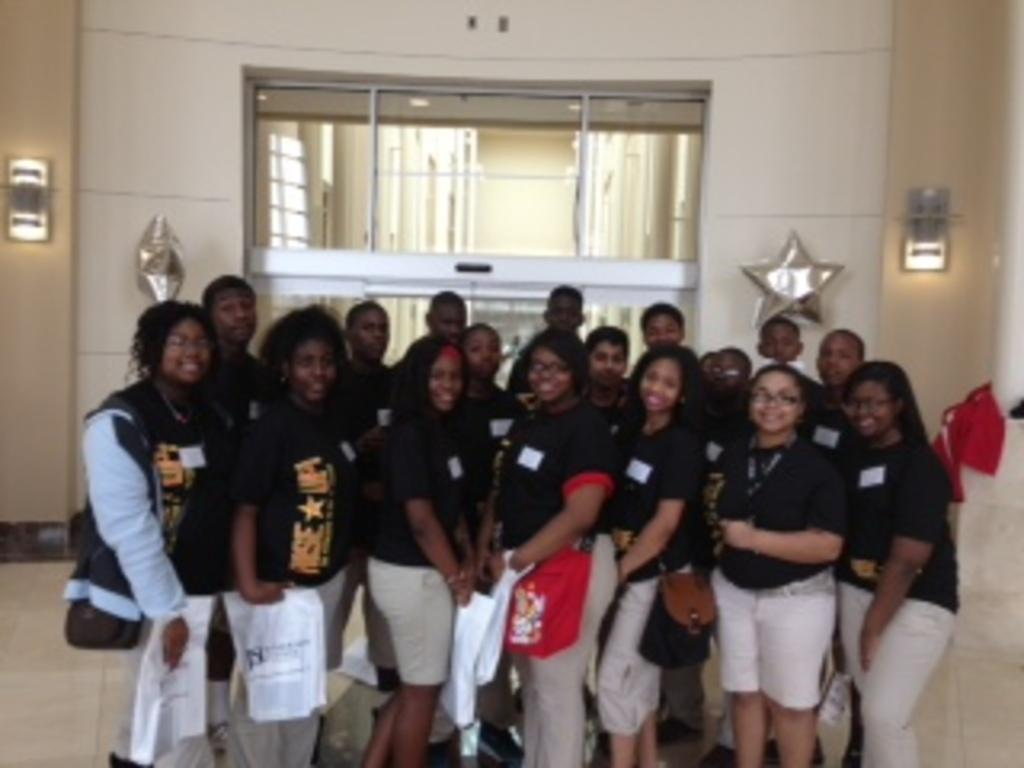How many people are visible in the image? There are many persons standing on the floor. What can be seen in the background of the image? There are windows, a door, stars, lights, and a wall visible in the background. What might be used for entering or exiting the room in the image? There is a door in the background that could be used for entering or exiting the room. What type of dress is being used for camping in the image? There is no dress or camping activity present in the image. 